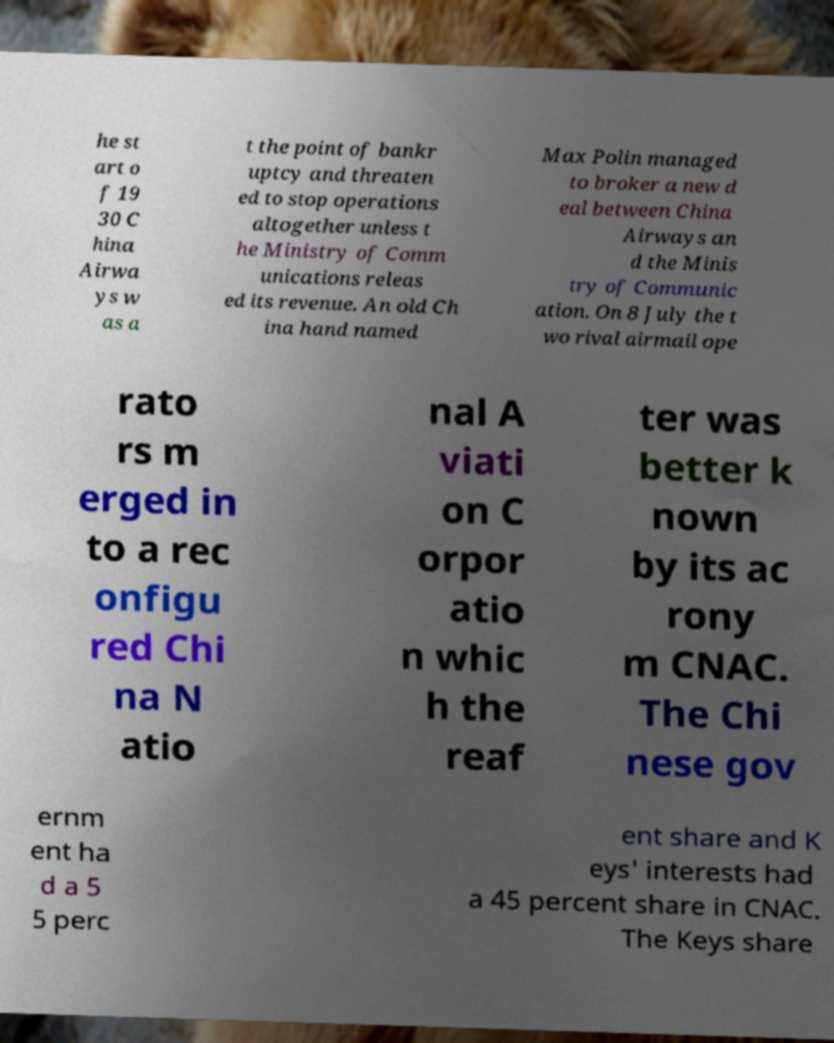Could you assist in decoding the text presented in this image and type it out clearly? he st art o f 19 30 C hina Airwa ys w as a t the point of bankr uptcy and threaten ed to stop operations altogether unless t he Ministry of Comm unications releas ed its revenue. An old Ch ina hand named Max Polin managed to broker a new d eal between China Airways an d the Minis try of Communic ation. On 8 July the t wo rival airmail ope rato rs m erged in to a rec onfigu red Chi na N atio nal A viati on C orpor atio n whic h the reaf ter was better k nown by its ac rony m CNAC. The Chi nese gov ernm ent ha d a 5 5 perc ent share and K eys' interests had a 45 percent share in CNAC. The Keys share 